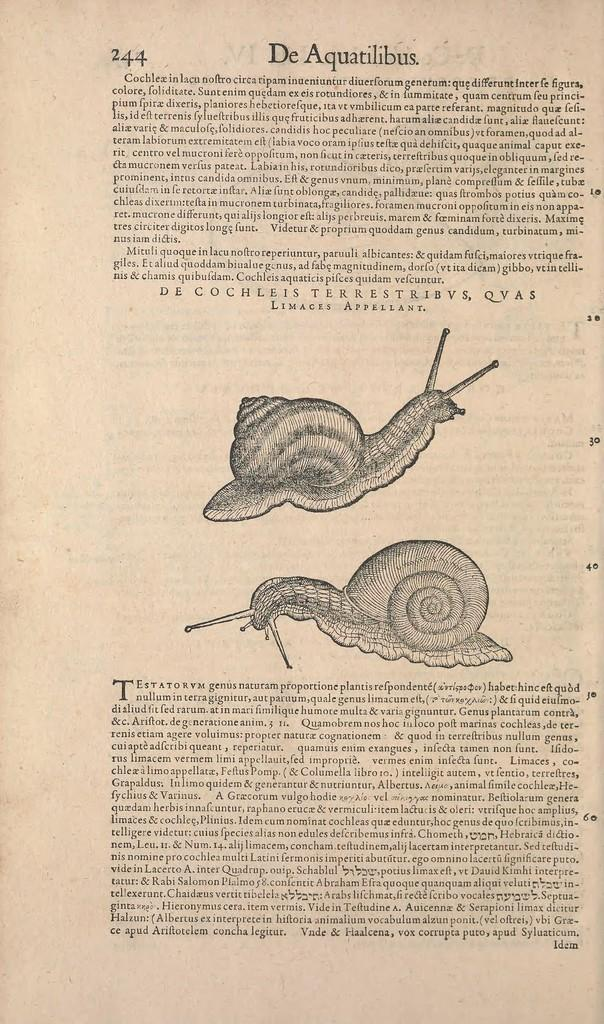What can be found in the image? There is text and images in the image. What is the source of the text and images? The text and images are taken from a book. What type of glass is used to make the decision in the image? There is no glass or decision-making process depicted in the image; it only contains text and images from a book. 